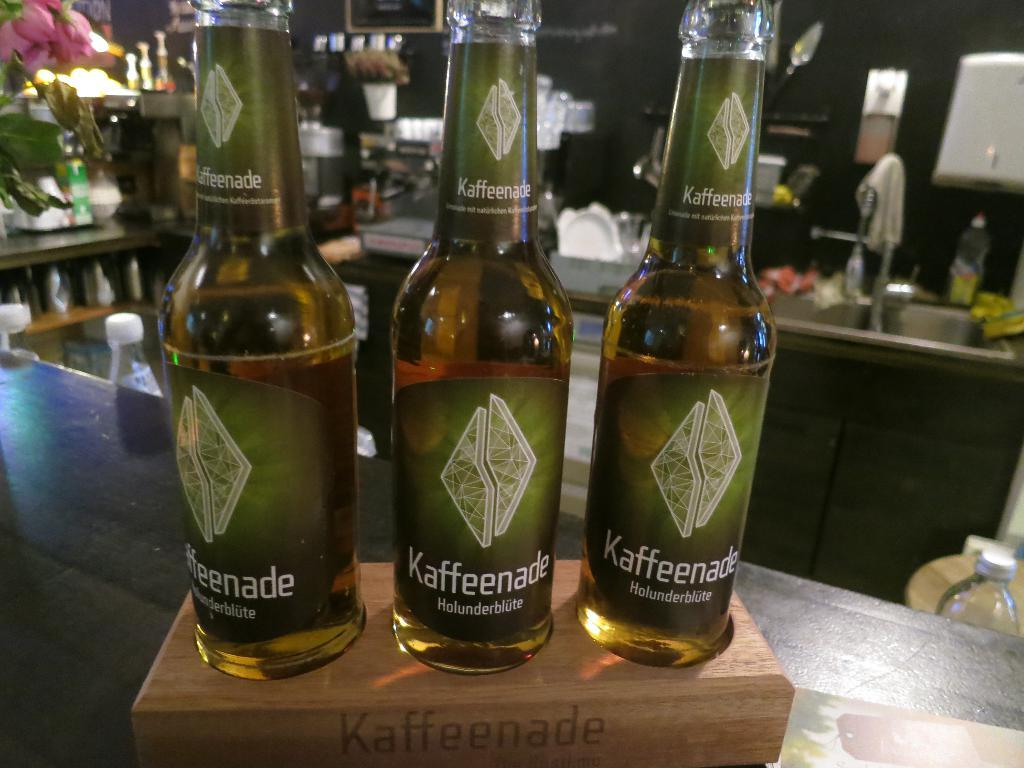What type of fixture is present in the image? There is a sink in the image. What is attached to the sink in the image? There is a tap in the image. What type of material is used for the walls in the image? There are tiles in the image. What type of kitchenware can be seen in the image? There are bowls and plates in the image. How many bottles are visible in the image? There are three bottles in the image. Can you tell me how many sisters are depicted in the image? There are no people, including sisters, present in the image. What type of brain is visible in the image? There is no brain present in the image. 